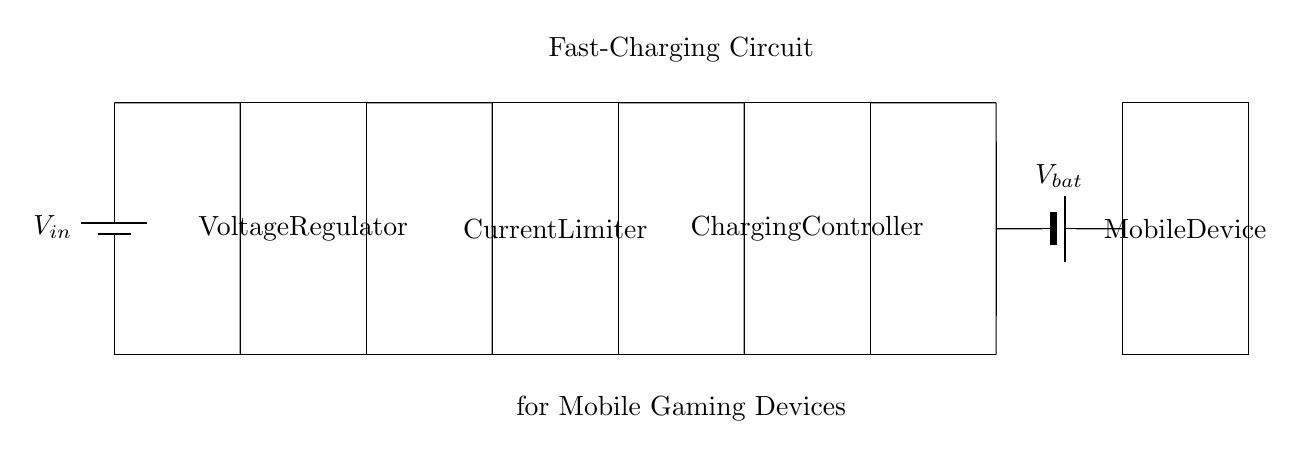What are the main components in this circuit? The main components are a battery, voltage regulator, current limiter, charging controller, and mobile device. These components are labeled in the diagram and are connected in sequence.
Answer: battery, voltage regulator, current limiter, charging controller, mobile device What is the purpose of the voltage regulator? The voltage regulator's purpose is to maintain a steady output voltage even when the input voltage or load conditions vary. It ensures that the mobile device receives a consistent voltage for charging.
Answer: maintain steady output voltage What does the charging controller do? The charging controller manages the charging process by regulating the amount of current supplied to the battery, ensuring safe and efficient charging while preventing overcharging.
Answer: manages charging process How many batteries are shown in this circuit? There are two batteries: one is the input battery providing power, and the other is the battery that is being charged within the mobile device.
Answer: two Which component is responsible for limiting the current? The current limiter is responsible for limiting the current flowing to the battery, protecting it from excessive current that could cause damage or overheating.
Answer: current limiter What will happen if the current limiter fails? If the current limiter fails, it can lead to excessive current flowing into the battery, potentially causing overheating, damage, or even a hazard such as a fire due to overcharging.
Answer: excessive current flow What is the main function of the entire circuit? The main function of the entire circuit is to charge the mobile device's battery quickly while minimizing downtime for gaming, ensuring that players can return to gaming as quickly as possible.
Answer: charge mobile device quickly 